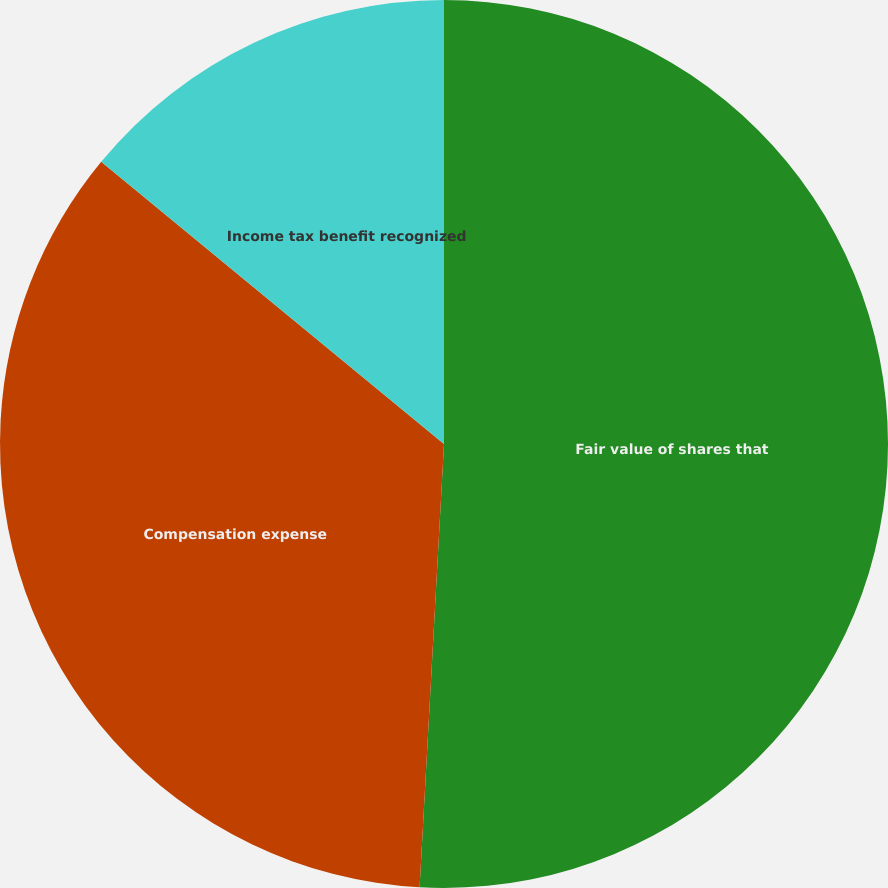Convert chart. <chart><loc_0><loc_0><loc_500><loc_500><pie_chart><fcel>Fair value of shares that<fcel>Compensation expense<fcel>Income tax benefit recognized<nl><fcel>50.88%<fcel>35.09%<fcel>14.04%<nl></chart> 